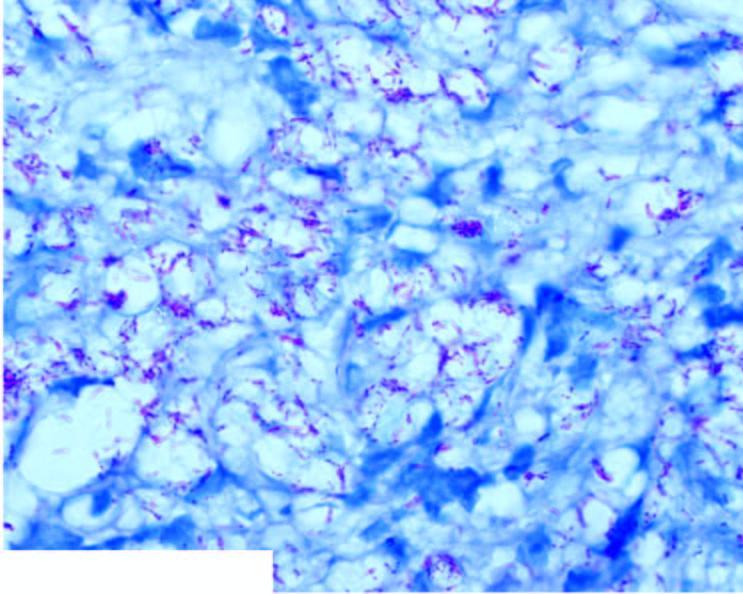what stain as globi and cigarettes-in-a-pack appearance inside the foam macrophages?
Answer the question using a single word or phrase. Lepra bacilli in ll seen in fite-faraco 